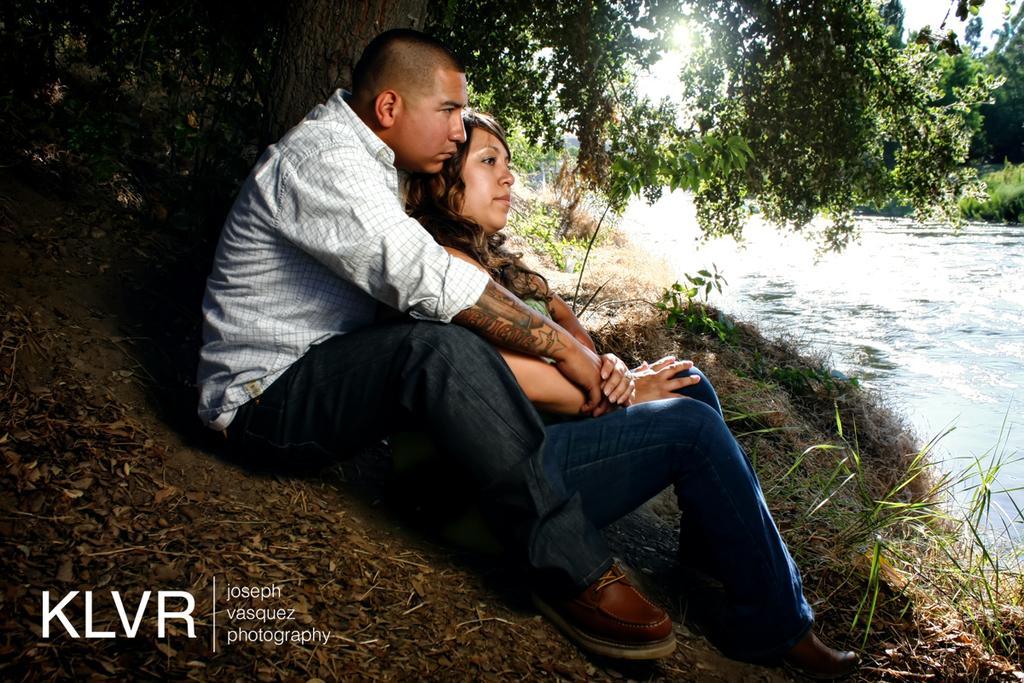Could you give a brief overview of what you see in this image? In this image we can see a man and a woman. On the right side there is water. Also we can see trees. On the ground there are few plants. In the left bottom corner something is written. 